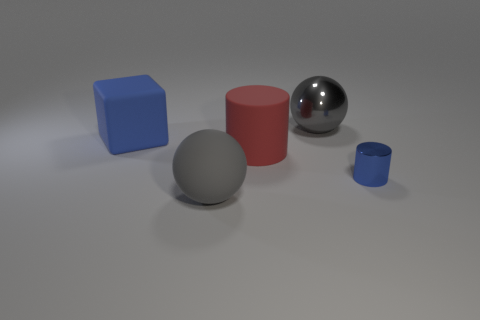There is a blue object that is on the left side of the metal cylinder; is it the same shape as the large gray thing that is on the left side of the large red cylinder?
Keep it short and to the point. No. How many other things are there of the same color as the rubber cylinder?
Give a very brief answer. 0. Do the gray object right of the gray rubber object and the matte cube have the same size?
Provide a succinct answer. Yes. Do the large thing that is behind the large blue block and the object that is in front of the blue metal thing have the same material?
Your answer should be compact. No. Are there any rubber objects of the same size as the red cylinder?
Give a very brief answer. Yes. There is a gray object left of the metallic sphere that is behind the gray ball in front of the shiny ball; what shape is it?
Make the answer very short. Sphere. Is the number of rubber things behind the tiny blue cylinder greater than the number of big gray metal balls?
Ensure brevity in your answer.  Yes. Is there another thing that has the same shape as the big shiny object?
Your response must be concise. Yes. Does the big red cylinder have the same material as the ball behind the blue cylinder?
Give a very brief answer. No. The large rubber block has what color?
Your answer should be very brief. Blue. 